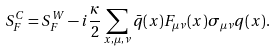Convert formula to latex. <formula><loc_0><loc_0><loc_500><loc_500>S _ { F } ^ { C } = S _ { F } ^ { W } - i \frac { \kappa } { 2 } \sum _ { x , \mu , \nu } \bar { q } ( x ) F _ { \mu \nu } ( x ) \sigma _ { \mu \nu } q ( x ) .</formula> 